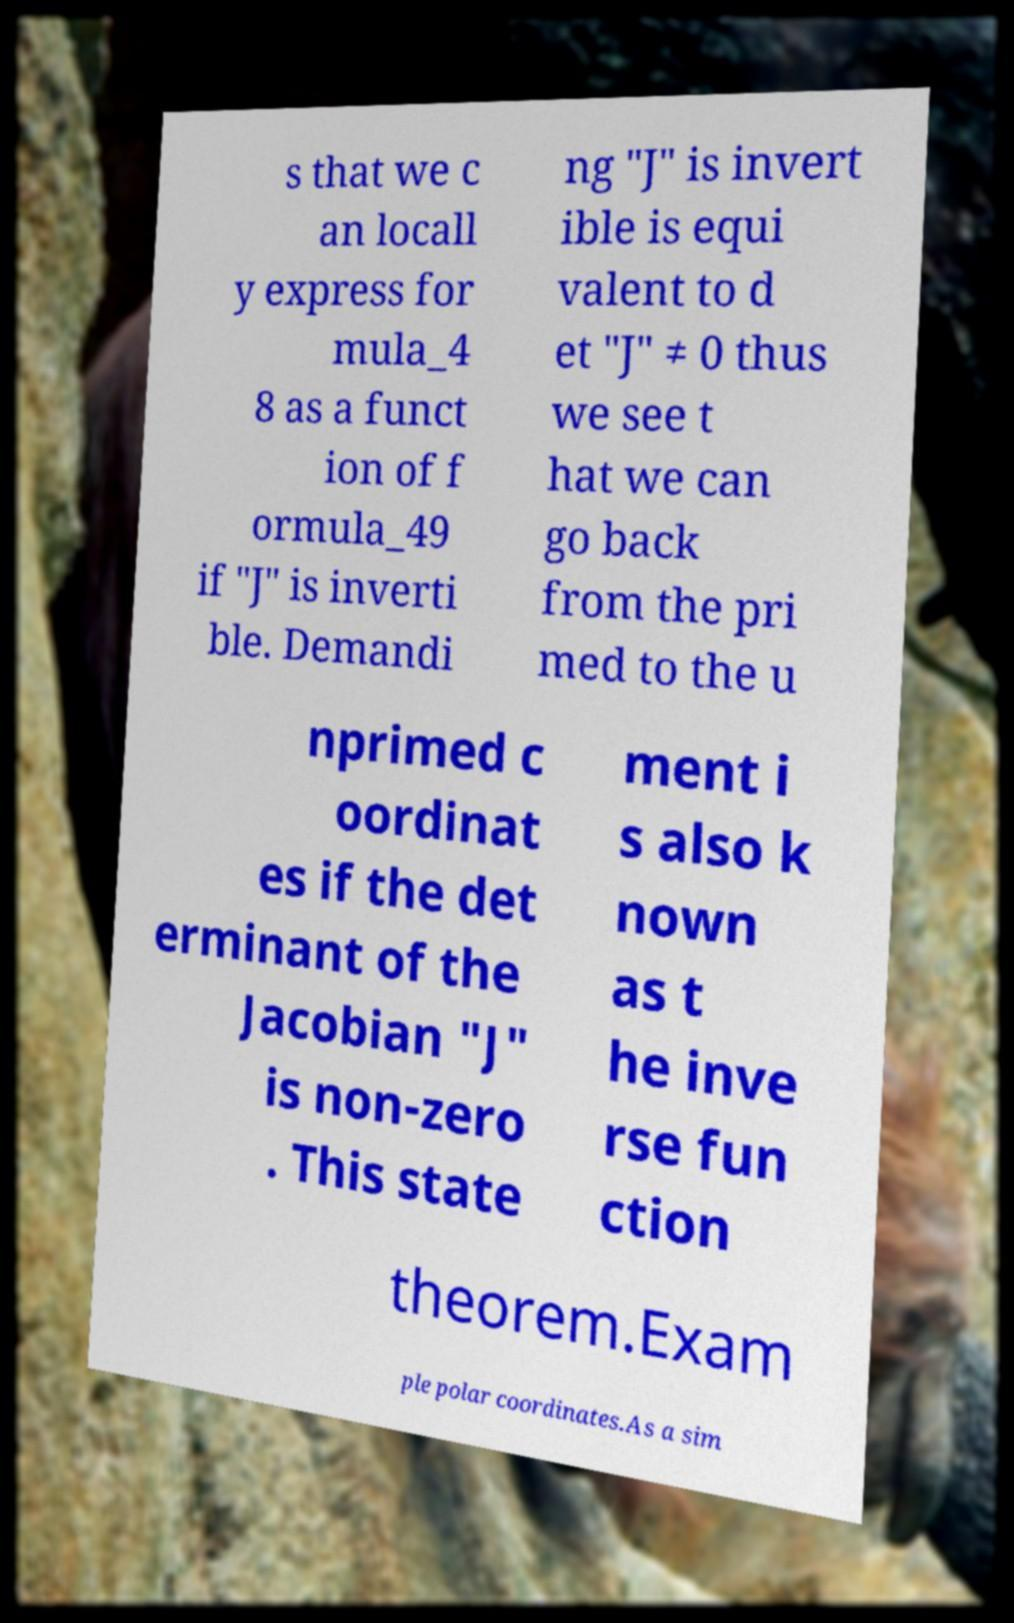For documentation purposes, I need the text within this image transcribed. Could you provide that? s that we c an locall y express for mula_4 8 as a funct ion of f ormula_49 if "J" is inverti ble. Demandi ng "J" is invert ible is equi valent to d et "J" ≠ 0 thus we see t hat we can go back from the pri med to the u nprimed c oordinat es if the det erminant of the Jacobian "J" is non-zero . This state ment i s also k nown as t he inve rse fun ction theorem.Exam ple polar coordinates.As a sim 